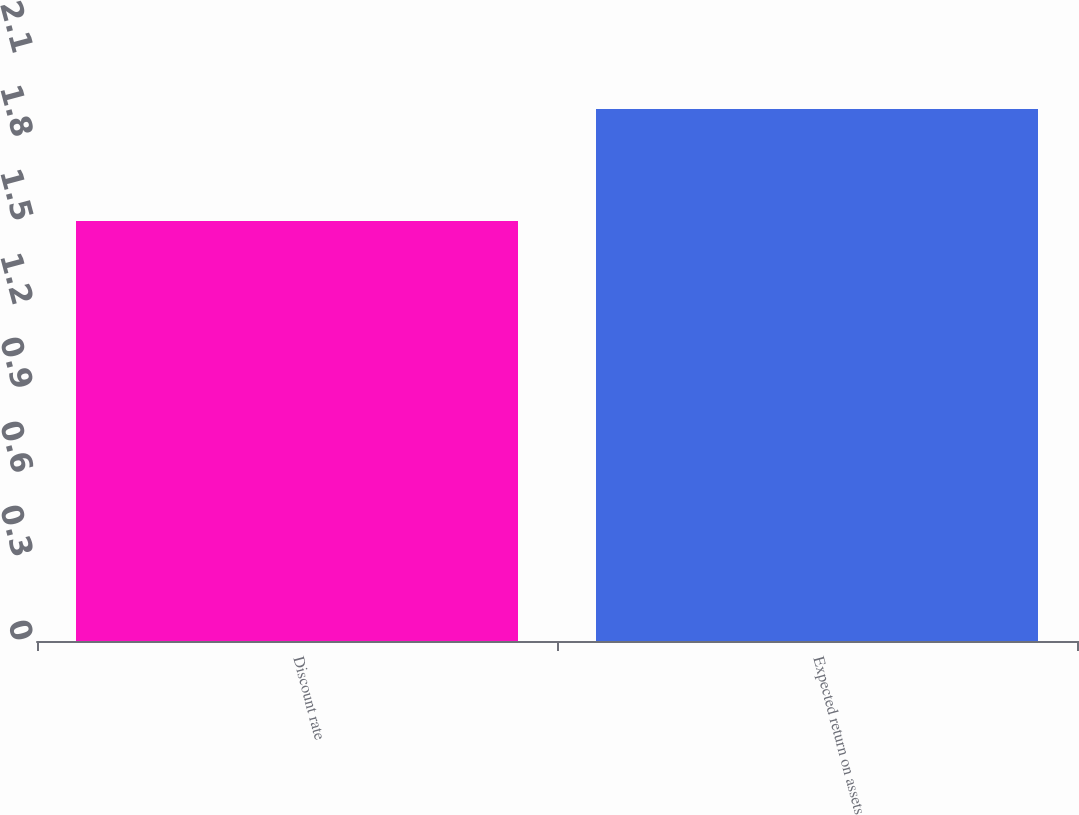Convert chart. <chart><loc_0><loc_0><loc_500><loc_500><bar_chart><fcel>Discount rate<fcel>Expected return on assets<nl><fcel>1.5<fcel>1.9<nl></chart> 